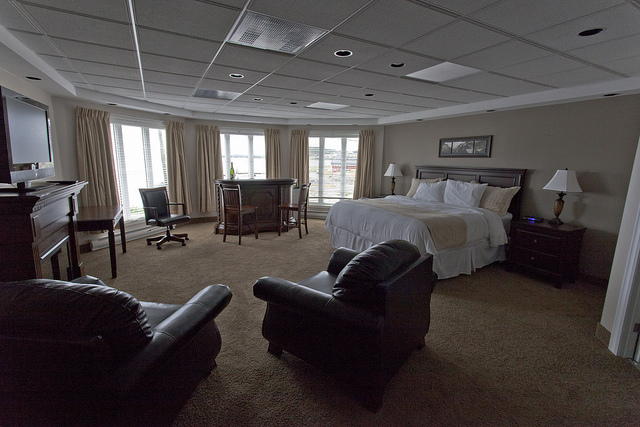<image>What color are the tablecloths? There are no tablecloths in the image. Or it could be white. What color are the tablecloths? I don't know what color the tablecloths are. It can be seen 'none', 'no tablecloth' or 'white'. 